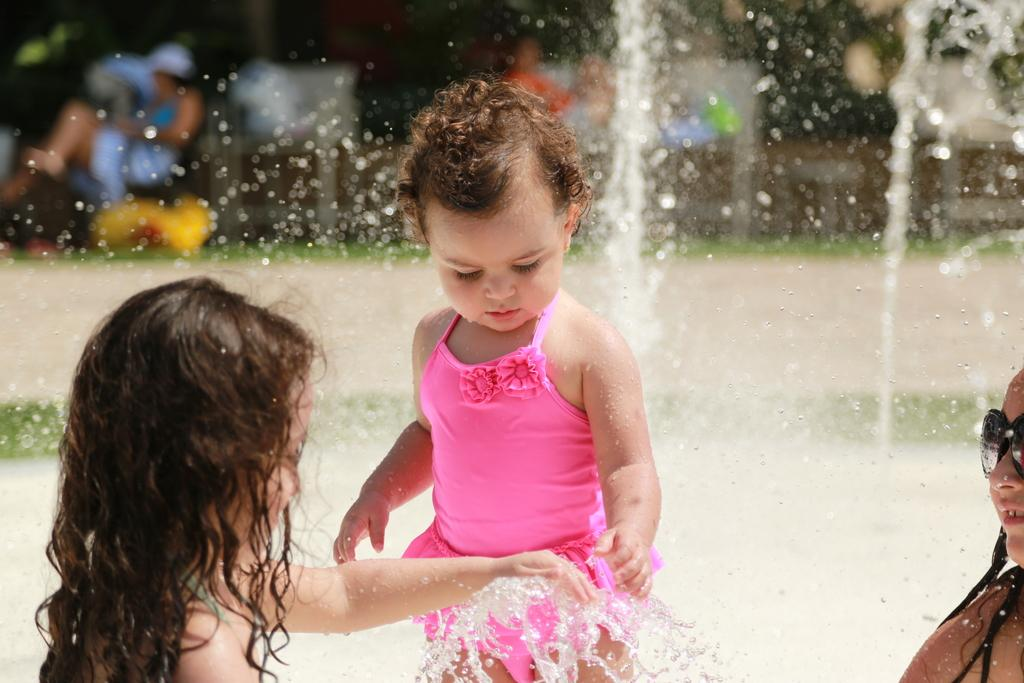How many children are present in the image? There are three children in the image. What are the children doing in the image? The children are playing in water. Can you describe the appearance of one of the children? One child on the right side is wearing goggles. What can be observed about the background of the image? The background of the image is blurred. What else can be seen in the image related to the water play? There are water droplets visible in the image. What year is the advertisement for the station featured in the image? There is no advertisement or station present in the image; it shows three children playing in water. 